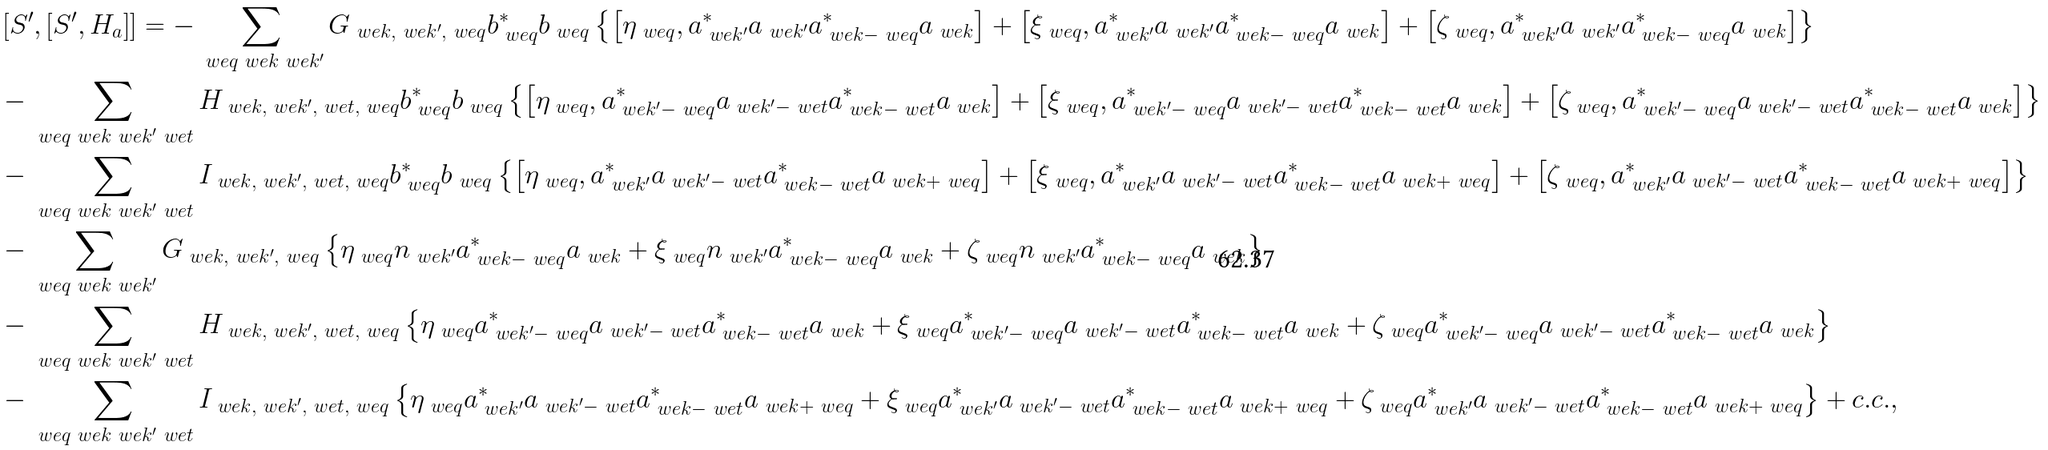Convert formula to latex. <formula><loc_0><loc_0><loc_500><loc_500>& \left [ S ^ { \prime } , \left [ S ^ { \prime } , H _ { a } \right ] \right ] = - \sum _ { \ w e { q } \ w e { k } \ w e { k ^ { \prime } } } G _ { \ w e { k } , \ w e { k ^ { \prime } } , \ w e { q } } b _ { \ w e { q } } ^ { \ast } b _ { \ w e { q } } \left \{ \left [ \eta _ { \ w e { q } } , a _ { \ w e { k ^ { \prime } } } ^ { \ast } a _ { \ w e { k ^ { \prime } } } a _ { \ w e { k } - \ w e { q } } ^ { \ast } a _ { \ w e { k } } \right ] + \left [ \xi _ { \ w e { q } } , a _ { \ w e { k ^ { \prime } } } ^ { \ast } a _ { \ w e { k ^ { \prime } } } a _ { \ w e { k } - \ w e { q } } ^ { \ast } a _ { \ w e { k } } \right ] + \left [ \zeta _ { \ w e { q } } , a _ { \ w e { k ^ { \prime } } } ^ { \ast } a _ { \ w e { k ^ { \prime } } } a _ { \ w e { k } - \ w e { q } } ^ { \ast } a _ { \ w e { k } } \right ] \right \} \\ & - \sum _ { \ w e { q } \ w e { k } \ w e { k ^ { \prime } } \ w e { t } } H _ { \ w e { k } , \ w e { k ^ { \prime } } , \ w e { t } , \ w e { q } } b _ { \ w e { q } } ^ { \ast } b _ { \ w e { q } } \left \{ \left [ \eta _ { \ w e { q } } , a _ { \ w e { k ^ { \prime } } - \ w e { q } } ^ { \ast } a _ { \ w e { k ^ { \prime } } - \ w e { t } } a _ { \ w e { k } - \ w e { t } } ^ { \ast } a _ { \ w e { k } } \right ] + \left [ \xi _ { \ w e { q } } , a _ { \ w e { k ^ { \prime } } - \ w e { q } } ^ { \ast } a _ { \ w e { k ^ { \prime } } - \ w e { t } } a _ { \ w e { k } - \ w e { t } } ^ { \ast } a _ { \ w e { k } } \right ] + \left [ \zeta _ { \ w e { q } } , a _ { \ w e { k ^ { \prime } } - \ w e { q } } ^ { \ast } a _ { \ w e { k ^ { \prime } } - \ w e { t } } a _ { \ w e { k } - \ w e { t } } ^ { \ast } a _ { \ w e { k } } \right ] \right \} \\ & - \sum _ { \ w e { q } \ w e { k } \ w e { k ^ { \prime } } \ w e { t } } I _ { \ w e { k } , \ w e { k ^ { \prime } } , \ w e { t } , \ w e { q } } b _ { \ w e { q } } ^ { \ast } b _ { \ w e { q } } \left \{ \left [ \eta _ { \ w e { q } } , a _ { \ w e { k ^ { \prime } } } ^ { \ast } a _ { \ w e { k ^ { \prime } } - \ w e { t } } a _ { \ w e { k } - \ w e { t } } ^ { \ast } a _ { \ w e { k } + \ w e { q } } \right ] + \left [ \xi _ { \ w e { q } } , a _ { \ w e { k ^ { \prime } } } ^ { \ast } a _ { \ w e { k ^ { \prime } } - \ w e { t } } a _ { \ w e { k } - \ w e { t } } ^ { \ast } a _ { \ w e { k } + \ w e { q } } \right ] + \left [ \zeta _ { \ w e { q } } , a _ { \ w e { k ^ { \prime } } } ^ { \ast } a _ { \ w e { k ^ { \prime } } - \ w e { t } } a _ { \ w e { k } - \ w e { t } } ^ { \ast } a _ { \ w e { k } + \ w e { q } } \right ] \right \} \\ & - \sum _ { \ w e { q } \ w e { k } \ w e { k ^ { \prime } } } G _ { \ w e { k } , \ w e { k ^ { \prime } } , \ w e { q } } \left \{ \eta _ { \ w e { q } } n _ { \ w e { k ^ { \prime } } } a _ { \ w e { k } - \ w e { q } } ^ { \ast } a _ { \ w e { k } } + \xi _ { \ w e { q } } n _ { \ w e { k ^ { \prime } } } a _ { \ w e { k } - \ w e { q } } ^ { \ast } a _ { \ w e { k } } + \zeta _ { \ w e { q } } n _ { \ w e { k ^ { \prime } } } a _ { \ w e { k } - \ w e { q } } ^ { \ast } a _ { \ w e { k } } \right \} \\ & - \sum _ { \ w e { q } \ w e { k } \ w e { k ^ { \prime } } \ w e { t } } H _ { \ w e { k } , \ w e { k ^ { \prime } } , \ w e { t } , \ w e { q } } \left \{ \eta _ { \ w e { q } } a _ { \ w e { k ^ { \prime } } - \ w e { q } } ^ { \ast } a _ { \ w e { k ^ { \prime } } - \ w e { t } } a _ { \ w e { k } - \ w e { t } } ^ { \ast } a _ { \ w e { k } } + \xi _ { \ w e { q } } a _ { \ w e { k ^ { \prime } } - \ w e { q } } ^ { \ast } a _ { \ w e { k ^ { \prime } } - \ w e { t } } a _ { \ w e { k } - \ w e { t } } ^ { \ast } a _ { \ w e { k } } + \zeta _ { \ w e { q } } a _ { \ w e { k ^ { \prime } } - \ w e { q } } ^ { \ast } a _ { \ w e { k ^ { \prime } } - \ w e { t } } a _ { \ w e { k } - \ w e { t } } ^ { \ast } a _ { \ w e { k } } \right \} \\ & - \sum _ { \ w e { q } \ w e { k } \ w e { k ^ { \prime } } \ w e { t } } I _ { \ w e { k } , \ w e { k ^ { \prime } } , \ w e { t } , \ w e { q } } \left \{ \eta _ { \ w e { q } } a _ { \ w e { k ^ { \prime } } } ^ { \ast } a _ { \ w e { k ^ { \prime } } - \ w e { t } } a _ { \ w e { k } - \ w e { t } } ^ { \ast } a _ { \ w e { k } + \ w e { q } } + \xi _ { \ w e { q } } a _ { \ w e { k ^ { \prime } } } ^ { \ast } a _ { \ w e { k ^ { \prime } } - \ w e { t } } a _ { \ w e { k } - \ w e { t } } ^ { \ast } a _ { \ w e { k } + \ w e { q } } + \zeta _ { \ w e { q } } a _ { \ w e { k ^ { \prime } } } ^ { \ast } a _ { \ w e { k ^ { \prime } } - \ w e { t } } a _ { \ w e { k } - \ w e { t } } ^ { \ast } a _ { \ w e { k } + \ w e { q } } \right \} + c . c . , \\</formula> 